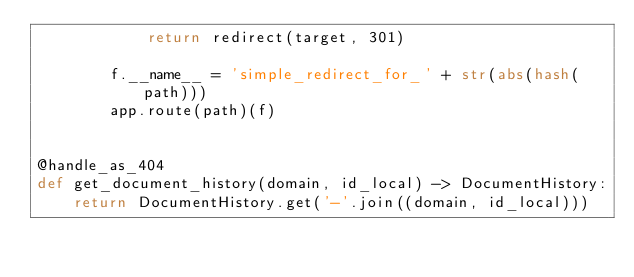Convert code to text. <code><loc_0><loc_0><loc_500><loc_500><_Python_>            return redirect(target, 301)

        f.__name__ = 'simple_redirect_for_' + str(abs(hash(path)))
        app.route(path)(f)


@handle_as_404
def get_document_history(domain, id_local) -> DocumentHistory:
    return DocumentHistory.get('-'.join((domain, id_local)))
</code> 